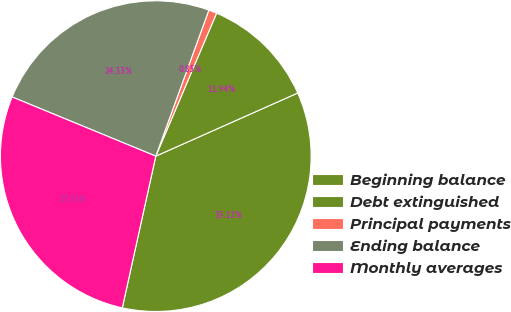Convert chart. <chart><loc_0><loc_0><loc_500><loc_500><pie_chart><fcel>Beginning balance<fcel>Debt extinguished<fcel>Principal payments<fcel>Ending balance<fcel>Monthly averages<nl><fcel>35.12%<fcel>11.94%<fcel>0.85%<fcel>24.33%<fcel>27.76%<nl></chart> 